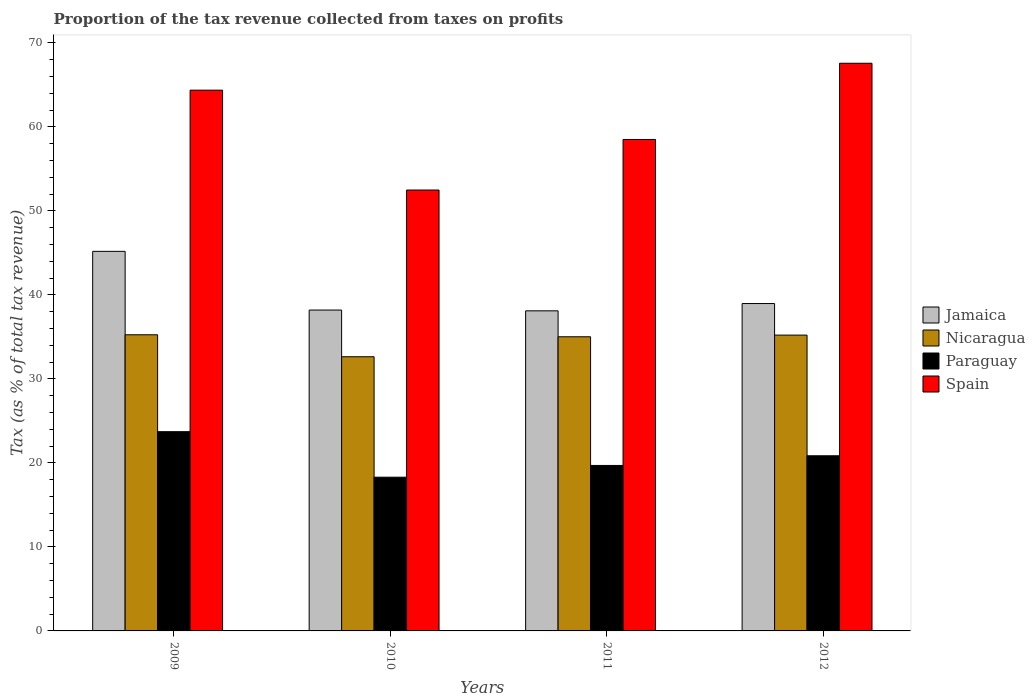How many different coloured bars are there?
Your answer should be very brief. 4. How many groups of bars are there?
Provide a succinct answer. 4. How many bars are there on the 3rd tick from the left?
Keep it short and to the point. 4. What is the label of the 1st group of bars from the left?
Make the answer very short. 2009. In how many cases, is the number of bars for a given year not equal to the number of legend labels?
Your answer should be very brief. 0. What is the proportion of the tax revenue collected in Spain in 2012?
Provide a succinct answer. 67.57. Across all years, what is the maximum proportion of the tax revenue collected in Spain?
Make the answer very short. 67.57. Across all years, what is the minimum proportion of the tax revenue collected in Nicaragua?
Your answer should be very brief. 32.64. In which year was the proportion of the tax revenue collected in Jamaica minimum?
Offer a terse response. 2011. What is the total proportion of the tax revenue collected in Paraguay in the graph?
Ensure brevity in your answer.  82.56. What is the difference between the proportion of the tax revenue collected in Jamaica in 2010 and that in 2011?
Keep it short and to the point. 0.09. What is the difference between the proportion of the tax revenue collected in Jamaica in 2009 and the proportion of the tax revenue collected in Paraguay in 2012?
Your response must be concise. 24.33. What is the average proportion of the tax revenue collected in Spain per year?
Provide a succinct answer. 60.73. In the year 2012, what is the difference between the proportion of the tax revenue collected in Spain and proportion of the tax revenue collected in Jamaica?
Ensure brevity in your answer.  28.6. In how many years, is the proportion of the tax revenue collected in Nicaragua greater than 40 %?
Offer a very short reply. 0. What is the ratio of the proportion of the tax revenue collected in Spain in 2010 to that in 2012?
Make the answer very short. 0.78. Is the difference between the proportion of the tax revenue collected in Spain in 2010 and 2012 greater than the difference between the proportion of the tax revenue collected in Jamaica in 2010 and 2012?
Keep it short and to the point. No. What is the difference between the highest and the second highest proportion of the tax revenue collected in Paraguay?
Keep it short and to the point. 2.87. What is the difference between the highest and the lowest proportion of the tax revenue collected in Spain?
Ensure brevity in your answer.  15.09. In how many years, is the proportion of the tax revenue collected in Spain greater than the average proportion of the tax revenue collected in Spain taken over all years?
Offer a very short reply. 2. Is the sum of the proportion of the tax revenue collected in Paraguay in 2010 and 2012 greater than the maximum proportion of the tax revenue collected in Spain across all years?
Provide a short and direct response. No. What does the 3rd bar from the left in 2012 represents?
Provide a succinct answer. Paraguay. What does the 2nd bar from the right in 2011 represents?
Offer a very short reply. Paraguay. Is it the case that in every year, the sum of the proportion of the tax revenue collected in Nicaragua and proportion of the tax revenue collected in Jamaica is greater than the proportion of the tax revenue collected in Paraguay?
Your response must be concise. Yes. How many bars are there?
Keep it short and to the point. 16. Are all the bars in the graph horizontal?
Offer a very short reply. No. How many years are there in the graph?
Your response must be concise. 4. Does the graph contain any zero values?
Give a very brief answer. No. Where does the legend appear in the graph?
Offer a terse response. Center right. How many legend labels are there?
Give a very brief answer. 4. How are the legend labels stacked?
Give a very brief answer. Vertical. What is the title of the graph?
Your response must be concise. Proportion of the tax revenue collected from taxes on profits. What is the label or title of the X-axis?
Ensure brevity in your answer.  Years. What is the label or title of the Y-axis?
Your response must be concise. Tax (as % of total tax revenue). What is the Tax (as % of total tax revenue) in Jamaica in 2009?
Give a very brief answer. 45.18. What is the Tax (as % of total tax revenue) in Nicaragua in 2009?
Ensure brevity in your answer.  35.25. What is the Tax (as % of total tax revenue) in Paraguay in 2009?
Make the answer very short. 23.72. What is the Tax (as % of total tax revenue) in Spain in 2009?
Your answer should be very brief. 64.37. What is the Tax (as % of total tax revenue) of Jamaica in 2010?
Your answer should be compact. 38.2. What is the Tax (as % of total tax revenue) in Nicaragua in 2010?
Offer a very short reply. 32.64. What is the Tax (as % of total tax revenue) of Paraguay in 2010?
Keep it short and to the point. 18.3. What is the Tax (as % of total tax revenue) in Spain in 2010?
Provide a succinct answer. 52.48. What is the Tax (as % of total tax revenue) of Jamaica in 2011?
Offer a terse response. 38.1. What is the Tax (as % of total tax revenue) of Nicaragua in 2011?
Ensure brevity in your answer.  35.02. What is the Tax (as % of total tax revenue) of Paraguay in 2011?
Offer a terse response. 19.7. What is the Tax (as % of total tax revenue) in Spain in 2011?
Offer a very short reply. 58.5. What is the Tax (as % of total tax revenue) of Jamaica in 2012?
Keep it short and to the point. 38.97. What is the Tax (as % of total tax revenue) of Nicaragua in 2012?
Provide a succinct answer. 35.21. What is the Tax (as % of total tax revenue) in Paraguay in 2012?
Your response must be concise. 20.85. What is the Tax (as % of total tax revenue) in Spain in 2012?
Keep it short and to the point. 67.57. Across all years, what is the maximum Tax (as % of total tax revenue) of Jamaica?
Keep it short and to the point. 45.18. Across all years, what is the maximum Tax (as % of total tax revenue) in Nicaragua?
Give a very brief answer. 35.25. Across all years, what is the maximum Tax (as % of total tax revenue) of Paraguay?
Your answer should be very brief. 23.72. Across all years, what is the maximum Tax (as % of total tax revenue) in Spain?
Ensure brevity in your answer.  67.57. Across all years, what is the minimum Tax (as % of total tax revenue) in Jamaica?
Your answer should be compact. 38.1. Across all years, what is the minimum Tax (as % of total tax revenue) in Nicaragua?
Make the answer very short. 32.64. Across all years, what is the minimum Tax (as % of total tax revenue) of Paraguay?
Your answer should be very brief. 18.3. Across all years, what is the minimum Tax (as % of total tax revenue) in Spain?
Offer a terse response. 52.48. What is the total Tax (as % of total tax revenue) in Jamaica in the graph?
Your response must be concise. 160.45. What is the total Tax (as % of total tax revenue) of Nicaragua in the graph?
Your answer should be compact. 138.12. What is the total Tax (as % of total tax revenue) in Paraguay in the graph?
Your answer should be compact. 82.56. What is the total Tax (as % of total tax revenue) in Spain in the graph?
Keep it short and to the point. 242.94. What is the difference between the Tax (as % of total tax revenue) in Jamaica in 2009 and that in 2010?
Your response must be concise. 6.99. What is the difference between the Tax (as % of total tax revenue) in Nicaragua in 2009 and that in 2010?
Offer a terse response. 2.62. What is the difference between the Tax (as % of total tax revenue) of Paraguay in 2009 and that in 2010?
Your response must be concise. 5.42. What is the difference between the Tax (as % of total tax revenue) in Spain in 2009 and that in 2010?
Your answer should be very brief. 11.89. What is the difference between the Tax (as % of total tax revenue) in Jamaica in 2009 and that in 2011?
Your answer should be compact. 7.08. What is the difference between the Tax (as % of total tax revenue) of Nicaragua in 2009 and that in 2011?
Your answer should be compact. 0.24. What is the difference between the Tax (as % of total tax revenue) in Paraguay in 2009 and that in 2011?
Offer a terse response. 4.02. What is the difference between the Tax (as % of total tax revenue) in Spain in 2009 and that in 2011?
Make the answer very short. 5.87. What is the difference between the Tax (as % of total tax revenue) of Jamaica in 2009 and that in 2012?
Provide a succinct answer. 6.21. What is the difference between the Tax (as % of total tax revenue) in Nicaragua in 2009 and that in 2012?
Give a very brief answer. 0.04. What is the difference between the Tax (as % of total tax revenue) of Paraguay in 2009 and that in 2012?
Your answer should be very brief. 2.87. What is the difference between the Tax (as % of total tax revenue) in Spain in 2009 and that in 2012?
Offer a very short reply. -3.2. What is the difference between the Tax (as % of total tax revenue) in Jamaica in 2010 and that in 2011?
Provide a short and direct response. 0.09. What is the difference between the Tax (as % of total tax revenue) in Nicaragua in 2010 and that in 2011?
Your answer should be very brief. -2.38. What is the difference between the Tax (as % of total tax revenue) of Paraguay in 2010 and that in 2011?
Your answer should be very brief. -1.4. What is the difference between the Tax (as % of total tax revenue) of Spain in 2010 and that in 2011?
Provide a short and direct response. -6.02. What is the difference between the Tax (as % of total tax revenue) of Jamaica in 2010 and that in 2012?
Your response must be concise. -0.78. What is the difference between the Tax (as % of total tax revenue) of Nicaragua in 2010 and that in 2012?
Provide a succinct answer. -2.58. What is the difference between the Tax (as % of total tax revenue) in Paraguay in 2010 and that in 2012?
Ensure brevity in your answer.  -2.55. What is the difference between the Tax (as % of total tax revenue) of Spain in 2010 and that in 2012?
Keep it short and to the point. -15.09. What is the difference between the Tax (as % of total tax revenue) in Jamaica in 2011 and that in 2012?
Provide a short and direct response. -0.87. What is the difference between the Tax (as % of total tax revenue) in Nicaragua in 2011 and that in 2012?
Your answer should be compact. -0.2. What is the difference between the Tax (as % of total tax revenue) in Paraguay in 2011 and that in 2012?
Give a very brief answer. -1.15. What is the difference between the Tax (as % of total tax revenue) in Spain in 2011 and that in 2012?
Provide a succinct answer. -9.07. What is the difference between the Tax (as % of total tax revenue) in Jamaica in 2009 and the Tax (as % of total tax revenue) in Nicaragua in 2010?
Provide a short and direct response. 12.55. What is the difference between the Tax (as % of total tax revenue) in Jamaica in 2009 and the Tax (as % of total tax revenue) in Paraguay in 2010?
Keep it short and to the point. 26.88. What is the difference between the Tax (as % of total tax revenue) of Jamaica in 2009 and the Tax (as % of total tax revenue) of Spain in 2010?
Your answer should be very brief. -7.3. What is the difference between the Tax (as % of total tax revenue) in Nicaragua in 2009 and the Tax (as % of total tax revenue) in Paraguay in 2010?
Provide a succinct answer. 16.96. What is the difference between the Tax (as % of total tax revenue) in Nicaragua in 2009 and the Tax (as % of total tax revenue) in Spain in 2010?
Your answer should be very brief. -17.23. What is the difference between the Tax (as % of total tax revenue) in Paraguay in 2009 and the Tax (as % of total tax revenue) in Spain in 2010?
Offer a terse response. -28.77. What is the difference between the Tax (as % of total tax revenue) in Jamaica in 2009 and the Tax (as % of total tax revenue) in Nicaragua in 2011?
Give a very brief answer. 10.17. What is the difference between the Tax (as % of total tax revenue) in Jamaica in 2009 and the Tax (as % of total tax revenue) in Paraguay in 2011?
Your answer should be very brief. 25.49. What is the difference between the Tax (as % of total tax revenue) of Jamaica in 2009 and the Tax (as % of total tax revenue) of Spain in 2011?
Provide a short and direct response. -13.32. What is the difference between the Tax (as % of total tax revenue) of Nicaragua in 2009 and the Tax (as % of total tax revenue) of Paraguay in 2011?
Ensure brevity in your answer.  15.56. What is the difference between the Tax (as % of total tax revenue) in Nicaragua in 2009 and the Tax (as % of total tax revenue) in Spain in 2011?
Give a very brief answer. -23.25. What is the difference between the Tax (as % of total tax revenue) of Paraguay in 2009 and the Tax (as % of total tax revenue) of Spain in 2011?
Provide a short and direct response. -34.79. What is the difference between the Tax (as % of total tax revenue) in Jamaica in 2009 and the Tax (as % of total tax revenue) in Nicaragua in 2012?
Offer a very short reply. 9.97. What is the difference between the Tax (as % of total tax revenue) of Jamaica in 2009 and the Tax (as % of total tax revenue) of Paraguay in 2012?
Your answer should be compact. 24.33. What is the difference between the Tax (as % of total tax revenue) of Jamaica in 2009 and the Tax (as % of total tax revenue) of Spain in 2012?
Offer a terse response. -22.39. What is the difference between the Tax (as % of total tax revenue) in Nicaragua in 2009 and the Tax (as % of total tax revenue) in Paraguay in 2012?
Offer a terse response. 14.4. What is the difference between the Tax (as % of total tax revenue) of Nicaragua in 2009 and the Tax (as % of total tax revenue) of Spain in 2012?
Offer a very short reply. -32.32. What is the difference between the Tax (as % of total tax revenue) in Paraguay in 2009 and the Tax (as % of total tax revenue) in Spain in 2012?
Your answer should be very brief. -43.86. What is the difference between the Tax (as % of total tax revenue) in Jamaica in 2010 and the Tax (as % of total tax revenue) in Nicaragua in 2011?
Provide a succinct answer. 3.18. What is the difference between the Tax (as % of total tax revenue) in Jamaica in 2010 and the Tax (as % of total tax revenue) in Paraguay in 2011?
Give a very brief answer. 18.5. What is the difference between the Tax (as % of total tax revenue) in Jamaica in 2010 and the Tax (as % of total tax revenue) in Spain in 2011?
Ensure brevity in your answer.  -20.31. What is the difference between the Tax (as % of total tax revenue) in Nicaragua in 2010 and the Tax (as % of total tax revenue) in Paraguay in 2011?
Provide a succinct answer. 12.94. What is the difference between the Tax (as % of total tax revenue) of Nicaragua in 2010 and the Tax (as % of total tax revenue) of Spain in 2011?
Make the answer very short. -25.87. What is the difference between the Tax (as % of total tax revenue) in Paraguay in 2010 and the Tax (as % of total tax revenue) in Spain in 2011?
Offer a very short reply. -40.21. What is the difference between the Tax (as % of total tax revenue) in Jamaica in 2010 and the Tax (as % of total tax revenue) in Nicaragua in 2012?
Provide a short and direct response. 2.98. What is the difference between the Tax (as % of total tax revenue) in Jamaica in 2010 and the Tax (as % of total tax revenue) in Paraguay in 2012?
Provide a short and direct response. 17.34. What is the difference between the Tax (as % of total tax revenue) in Jamaica in 2010 and the Tax (as % of total tax revenue) in Spain in 2012?
Provide a short and direct response. -29.38. What is the difference between the Tax (as % of total tax revenue) of Nicaragua in 2010 and the Tax (as % of total tax revenue) of Paraguay in 2012?
Provide a succinct answer. 11.79. What is the difference between the Tax (as % of total tax revenue) of Nicaragua in 2010 and the Tax (as % of total tax revenue) of Spain in 2012?
Provide a succinct answer. -34.94. What is the difference between the Tax (as % of total tax revenue) in Paraguay in 2010 and the Tax (as % of total tax revenue) in Spain in 2012?
Your response must be concise. -49.28. What is the difference between the Tax (as % of total tax revenue) of Jamaica in 2011 and the Tax (as % of total tax revenue) of Nicaragua in 2012?
Give a very brief answer. 2.89. What is the difference between the Tax (as % of total tax revenue) of Jamaica in 2011 and the Tax (as % of total tax revenue) of Paraguay in 2012?
Offer a very short reply. 17.25. What is the difference between the Tax (as % of total tax revenue) of Jamaica in 2011 and the Tax (as % of total tax revenue) of Spain in 2012?
Provide a succinct answer. -29.47. What is the difference between the Tax (as % of total tax revenue) in Nicaragua in 2011 and the Tax (as % of total tax revenue) in Paraguay in 2012?
Provide a succinct answer. 14.17. What is the difference between the Tax (as % of total tax revenue) of Nicaragua in 2011 and the Tax (as % of total tax revenue) of Spain in 2012?
Offer a terse response. -32.56. What is the difference between the Tax (as % of total tax revenue) in Paraguay in 2011 and the Tax (as % of total tax revenue) in Spain in 2012?
Offer a very short reply. -47.88. What is the average Tax (as % of total tax revenue) in Jamaica per year?
Offer a very short reply. 40.11. What is the average Tax (as % of total tax revenue) of Nicaragua per year?
Provide a succinct answer. 34.53. What is the average Tax (as % of total tax revenue) in Paraguay per year?
Provide a succinct answer. 20.64. What is the average Tax (as % of total tax revenue) in Spain per year?
Provide a succinct answer. 60.73. In the year 2009, what is the difference between the Tax (as % of total tax revenue) in Jamaica and Tax (as % of total tax revenue) in Nicaragua?
Make the answer very short. 9.93. In the year 2009, what is the difference between the Tax (as % of total tax revenue) of Jamaica and Tax (as % of total tax revenue) of Paraguay?
Ensure brevity in your answer.  21.47. In the year 2009, what is the difference between the Tax (as % of total tax revenue) of Jamaica and Tax (as % of total tax revenue) of Spain?
Offer a terse response. -19.19. In the year 2009, what is the difference between the Tax (as % of total tax revenue) in Nicaragua and Tax (as % of total tax revenue) in Paraguay?
Your answer should be very brief. 11.54. In the year 2009, what is the difference between the Tax (as % of total tax revenue) of Nicaragua and Tax (as % of total tax revenue) of Spain?
Provide a short and direct response. -29.12. In the year 2009, what is the difference between the Tax (as % of total tax revenue) in Paraguay and Tax (as % of total tax revenue) in Spain?
Offer a very short reply. -40.65. In the year 2010, what is the difference between the Tax (as % of total tax revenue) of Jamaica and Tax (as % of total tax revenue) of Nicaragua?
Offer a very short reply. 5.56. In the year 2010, what is the difference between the Tax (as % of total tax revenue) of Jamaica and Tax (as % of total tax revenue) of Paraguay?
Offer a very short reply. 19.9. In the year 2010, what is the difference between the Tax (as % of total tax revenue) of Jamaica and Tax (as % of total tax revenue) of Spain?
Offer a very short reply. -14.29. In the year 2010, what is the difference between the Tax (as % of total tax revenue) in Nicaragua and Tax (as % of total tax revenue) in Paraguay?
Your answer should be compact. 14.34. In the year 2010, what is the difference between the Tax (as % of total tax revenue) in Nicaragua and Tax (as % of total tax revenue) in Spain?
Provide a succinct answer. -19.85. In the year 2010, what is the difference between the Tax (as % of total tax revenue) in Paraguay and Tax (as % of total tax revenue) in Spain?
Provide a succinct answer. -34.19. In the year 2011, what is the difference between the Tax (as % of total tax revenue) in Jamaica and Tax (as % of total tax revenue) in Nicaragua?
Make the answer very short. 3.09. In the year 2011, what is the difference between the Tax (as % of total tax revenue) of Jamaica and Tax (as % of total tax revenue) of Paraguay?
Your answer should be very brief. 18.4. In the year 2011, what is the difference between the Tax (as % of total tax revenue) of Jamaica and Tax (as % of total tax revenue) of Spain?
Make the answer very short. -20.4. In the year 2011, what is the difference between the Tax (as % of total tax revenue) in Nicaragua and Tax (as % of total tax revenue) in Paraguay?
Provide a short and direct response. 15.32. In the year 2011, what is the difference between the Tax (as % of total tax revenue) of Nicaragua and Tax (as % of total tax revenue) of Spain?
Your answer should be compact. -23.49. In the year 2011, what is the difference between the Tax (as % of total tax revenue) of Paraguay and Tax (as % of total tax revenue) of Spain?
Keep it short and to the point. -38.81. In the year 2012, what is the difference between the Tax (as % of total tax revenue) in Jamaica and Tax (as % of total tax revenue) in Nicaragua?
Give a very brief answer. 3.76. In the year 2012, what is the difference between the Tax (as % of total tax revenue) of Jamaica and Tax (as % of total tax revenue) of Paraguay?
Provide a succinct answer. 18.12. In the year 2012, what is the difference between the Tax (as % of total tax revenue) of Jamaica and Tax (as % of total tax revenue) of Spain?
Ensure brevity in your answer.  -28.6. In the year 2012, what is the difference between the Tax (as % of total tax revenue) of Nicaragua and Tax (as % of total tax revenue) of Paraguay?
Offer a very short reply. 14.36. In the year 2012, what is the difference between the Tax (as % of total tax revenue) in Nicaragua and Tax (as % of total tax revenue) in Spain?
Offer a very short reply. -32.36. In the year 2012, what is the difference between the Tax (as % of total tax revenue) in Paraguay and Tax (as % of total tax revenue) in Spain?
Offer a very short reply. -46.72. What is the ratio of the Tax (as % of total tax revenue) in Jamaica in 2009 to that in 2010?
Offer a terse response. 1.18. What is the ratio of the Tax (as % of total tax revenue) in Nicaragua in 2009 to that in 2010?
Ensure brevity in your answer.  1.08. What is the ratio of the Tax (as % of total tax revenue) of Paraguay in 2009 to that in 2010?
Provide a succinct answer. 1.3. What is the ratio of the Tax (as % of total tax revenue) of Spain in 2009 to that in 2010?
Your response must be concise. 1.23. What is the ratio of the Tax (as % of total tax revenue) of Jamaica in 2009 to that in 2011?
Your answer should be very brief. 1.19. What is the ratio of the Tax (as % of total tax revenue) of Nicaragua in 2009 to that in 2011?
Provide a succinct answer. 1.01. What is the ratio of the Tax (as % of total tax revenue) of Paraguay in 2009 to that in 2011?
Give a very brief answer. 1.2. What is the ratio of the Tax (as % of total tax revenue) of Spain in 2009 to that in 2011?
Provide a succinct answer. 1.1. What is the ratio of the Tax (as % of total tax revenue) in Jamaica in 2009 to that in 2012?
Keep it short and to the point. 1.16. What is the ratio of the Tax (as % of total tax revenue) in Paraguay in 2009 to that in 2012?
Your answer should be compact. 1.14. What is the ratio of the Tax (as % of total tax revenue) in Spain in 2009 to that in 2012?
Your answer should be very brief. 0.95. What is the ratio of the Tax (as % of total tax revenue) of Nicaragua in 2010 to that in 2011?
Provide a short and direct response. 0.93. What is the ratio of the Tax (as % of total tax revenue) in Paraguay in 2010 to that in 2011?
Your response must be concise. 0.93. What is the ratio of the Tax (as % of total tax revenue) of Spain in 2010 to that in 2011?
Keep it short and to the point. 0.9. What is the ratio of the Tax (as % of total tax revenue) of Jamaica in 2010 to that in 2012?
Offer a terse response. 0.98. What is the ratio of the Tax (as % of total tax revenue) in Nicaragua in 2010 to that in 2012?
Give a very brief answer. 0.93. What is the ratio of the Tax (as % of total tax revenue) in Paraguay in 2010 to that in 2012?
Your answer should be compact. 0.88. What is the ratio of the Tax (as % of total tax revenue) in Spain in 2010 to that in 2012?
Offer a very short reply. 0.78. What is the ratio of the Tax (as % of total tax revenue) in Jamaica in 2011 to that in 2012?
Keep it short and to the point. 0.98. What is the ratio of the Tax (as % of total tax revenue) of Paraguay in 2011 to that in 2012?
Provide a short and direct response. 0.94. What is the ratio of the Tax (as % of total tax revenue) in Spain in 2011 to that in 2012?
Give a very brief answer. 0.87. What is the difference between the highest and the second highest Tax (as % of total tax revenue) in Jamaica?
Your answer should be very brief. 6.21. What is the difference between the highest and the second highest Tax (as % of total tax revenue) in Nicaragua?
Ensure brevity in your answer.  0.04. What is the difference between the highest and the second highest Tax (as % of total tax revenue) in Paraguay?
Give a very brief answer. 2.87. What is the difference between the highest and the second highest Tax (as % of total tax revenue) of Spain?
Make the answer very short. 3.2. What is the difference between the highest and the lowest Tax (as % of total tax revenue) in Jamaica?
Offer a terse response. 7.08. What is the difference between the highest and the lowest Tax (as % of total tax revenue) of Nicaragua?
Provide a short and direct response. 2.62. What is the difference between the highest and the lowest Tax (as % of total tax revenue) in Paraguay?
Give a very brief answer. 5.42. What is the difference between the highest and the lowest Tax (as % of total tax revenue) of Spain?
Offer a very short reply. 15.09. 